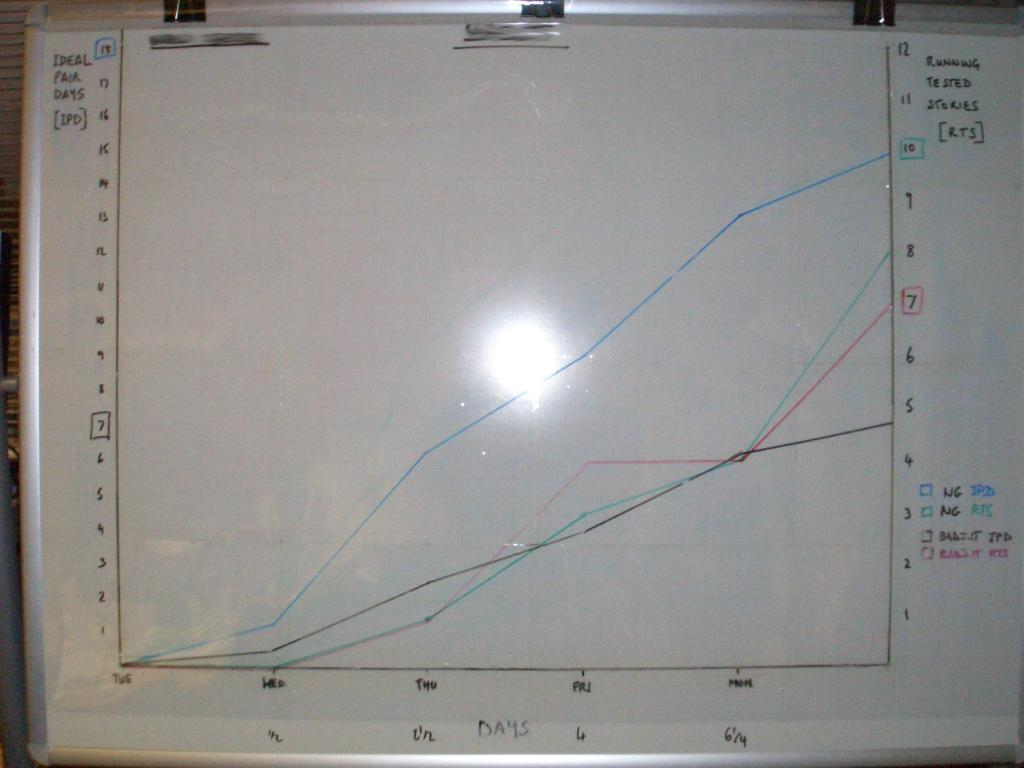What is the main object in the center of the image? There is a board in the center of the image. What can be found on the board? There is text written on the board and diagrams on the board. What type of lace is draped over the board in the image? There is no lace present in the image; the board contains text and diagrams. 